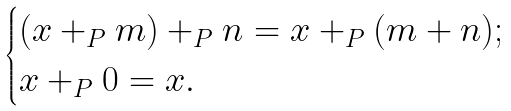Convert formula to latex. <formula><loc_0><loc_0><loc_500><loc_500>\begin{cases} ( x + _ { P } m ) + _ { P } n = x + _ { P } ( m + n ) ; \\ x + _ { P } 0 = x . \end{cases}</formula> 